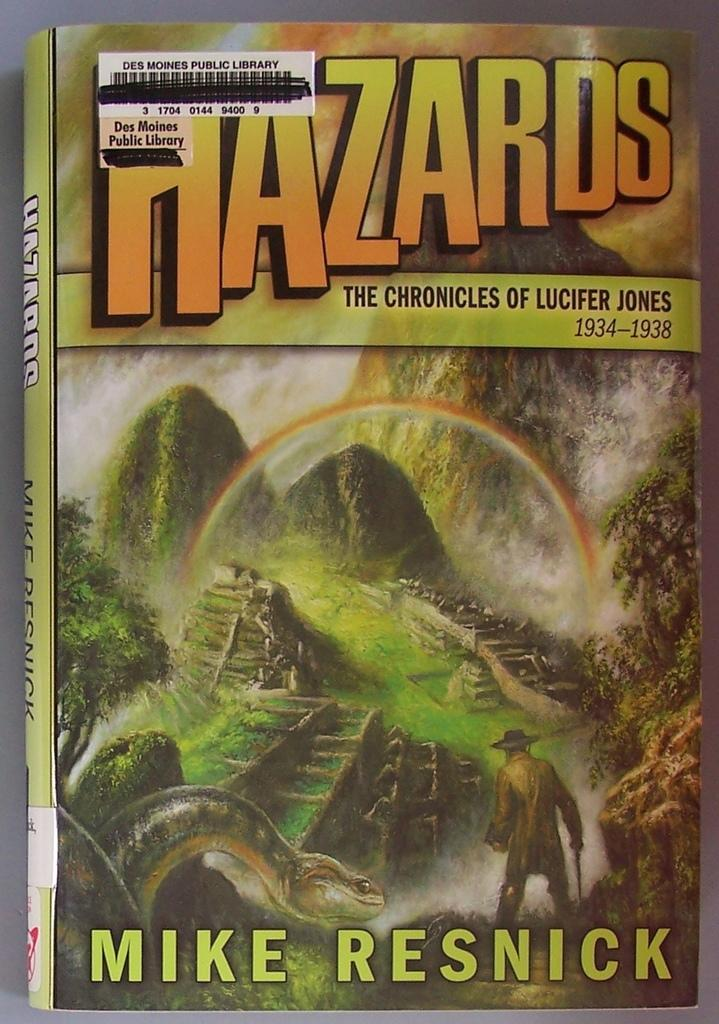<image>
Offer a succinct explanation of the picture presented. the cover of the book titled hazards by mike resnick. 